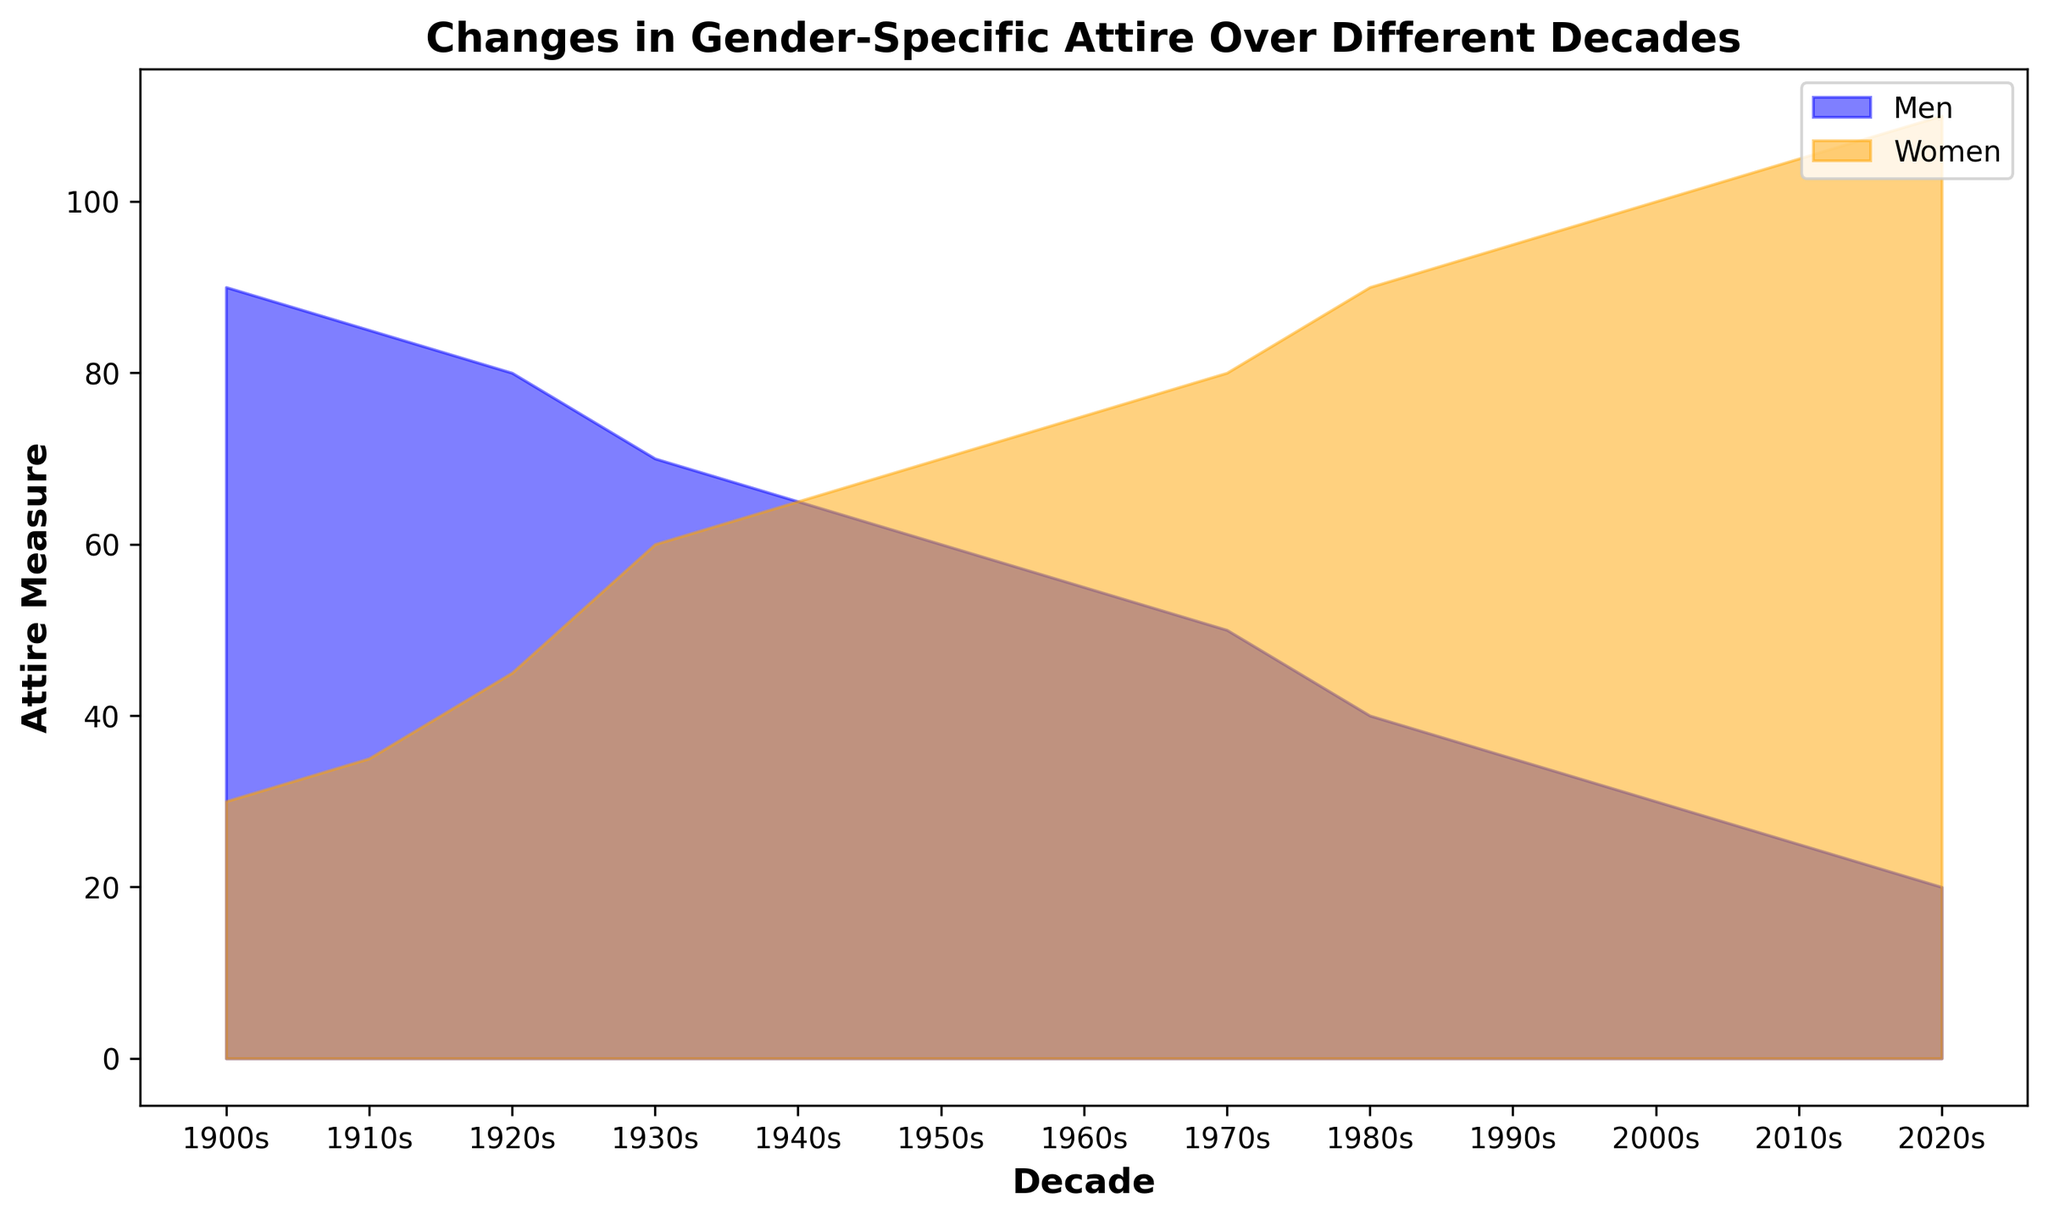Which decade had the highest attire measure for women? In the area chart, the highest point for the "Women" series shows the maximum value. The highest value for "Women" is in the 2020s, marked at 110.
Answer: 2020s Which decade had the lowest attire measure for men? By finding the lowest point in the "Men" series, we can identify the decade. The lowest value for "Men" is in the 2020s, marked at 20.
Answer: 2020s Did the attire measure of women ever equal the attire measure of men? Observing the area chart, the lines for "Men" and "Women" intersect in the 1940s. Both men and women have an attire measure of 65 at that point.
Answer: Yes, in the 1940s What is the total attire measure for both men and women combined in the 1990s? Sum the attire measures of men and women for the 1990s. Men have 35, and women have 95. Adding them together gives 35 + 95 = 130.
Answer: 130 How did the attire measure for men change from the 1900s to the 2000s? Subtract the measure for men in the 2000s from the measure in the 1900s. In the 1900s, it was 90, and in the 2000s, it was 30. So, 90 - 30 = 60.
Answer: Decreased by 60 In which decade did women’s attire measure first surpass men’s? Identify the decade where the "Women" series crosses above the "Men" series for the first time. This happens in the 1940s.
Answer: 1940s What is the difference in attire measures between men and women in the 2010s? Subtract the measure for men from the measure for women in the 2010s. Women have 105, and men have 25. So, 105 - 25 = 80.
Answer: 80 Which gender experienced a greater rate of change in attire measure from the 1900s to the 2020s? Calculate the rate of change for both men and women by finding the difference in their measures and dividing by the range of decades. For men, the change is 90 - 20 = 70; for women, it's 30 - 110 = 80. Since women experienced an 80-unit change over 12 decades (80/12 = 6.67) and men a 70-unit change over 12 decades (70/12 = 5.83), the women had a greater rate of change.
Answer: Women 